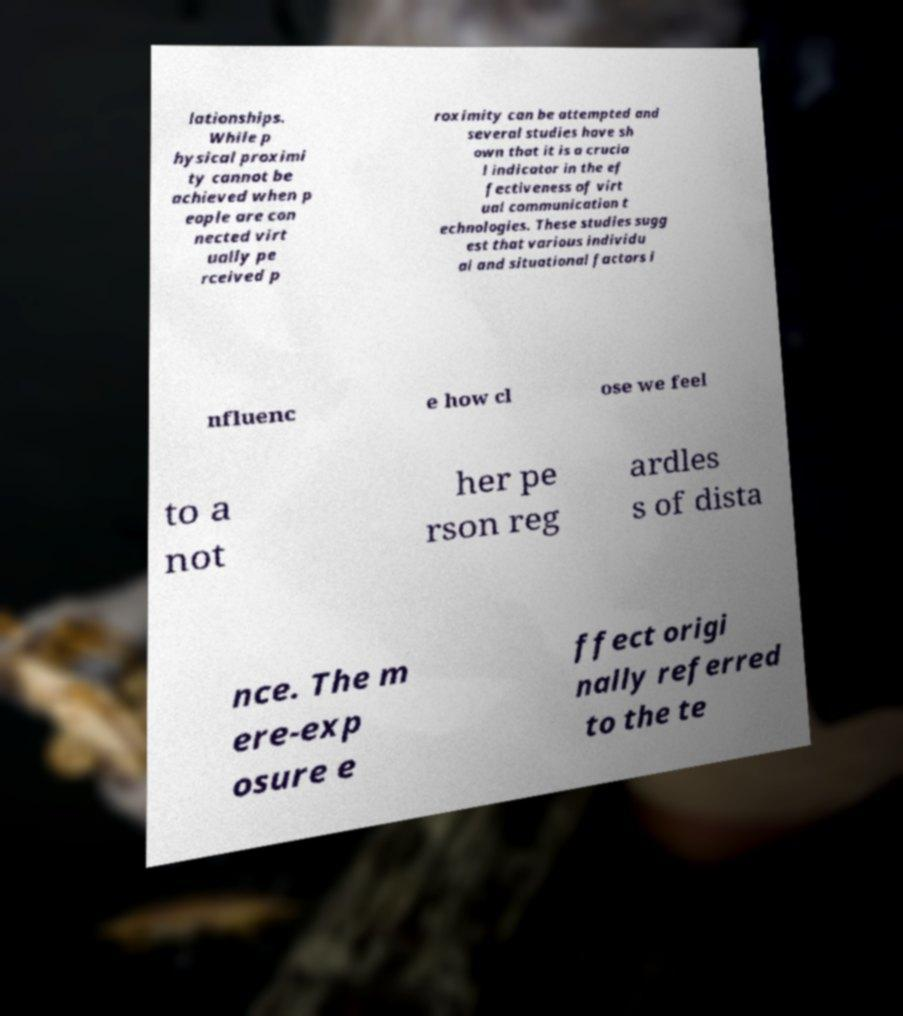There's text embedded in this image that I need extracted. Can you transcribe it verbatim? lationships. While p hysical proximi ty cannot be achieved when p eople are con nected virt ually pe rceived p roximity can be attempted and several studies have sh own that it is a crucia l indicator in the ef fectiveness of virt ual communication t echnologies. These studies sugg est that various individu al and situational factors i nfluenc e how cl ose we feel to a not her pe rson reg ardles s of dista nce. The m ere-exp osure e ffect origi nally referred to the te 